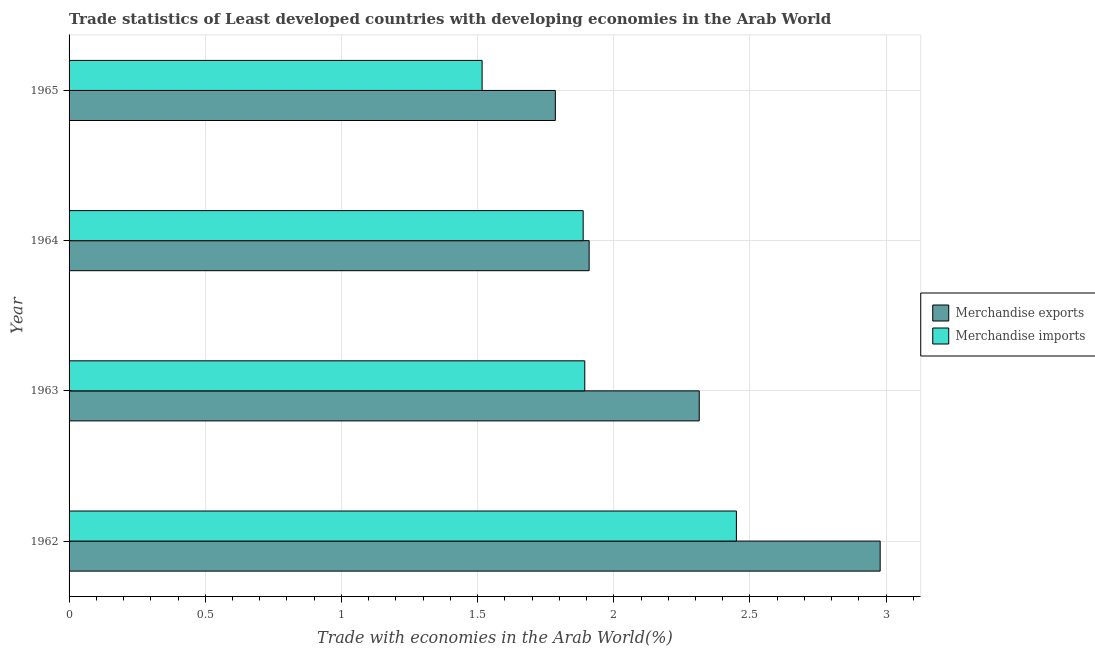How many different coloured bars are there?
Keep it short and to the point. 2. How many groups of bars are there?
Offer a very short reply. 4. Are the number of bars per tick equal to the number of legend labels?
Make the answer very short. Yes. Are the number of bars on each tick of the Y-axis equal?
Provide a short and direct response. Yes. How many bars are there on the 4th tick from the top?
Your response must be concise. 2. What is the label of the 3rd group of bars from the top?
Your answer should be very brief. 1963. In how many cases, is the number of bars for a given year not equal to the number of legend labels?
Offer a very short reply. 0. What is the merchandise exports in 1964?
Your answer should be compact. 1.91. Across all years, what is the maximum merchandise exports?
Offer a terse response. 2.98. Across all years, what is the minimum merchandise exports?
Make the answer very short. 1.79. In which year was the merchandise exports maximum?
Provide a short and direct response. 1962. In which year was the merchandise exports minimum?
Offer a very short reply. 1965. What is the total merchandise imports in the graph?
Your answer should be compact. 7.75. What is the difference between the merchandise imports in 1963 and that in 1965?
Your response must be concise. 0.38. What is the difference between the merchandise exports in 1962 and the merchandise imports in 1964?
Offer a very short reply. 1.09. What is the average merchandise exports per year?
Your answer should be compact. 2.25. In the year 1962, what is the difference between the merchandise exports and merchandise imports?
Your response must be concise. 0.53. In how many years, is the merchandise imports greater than 1.7 %?
Provide a short and direct response. 3. What is the ratio of the merchandise imports in 1962 to that in 1963?
Offer a terse response. 1.29. Is the merchandise imports in 1964 less than that in 1965?
Your answer should be very brief. No. What is the difference between the highest and the second highest merchandise exports?
Provide a short and direct response. 0.66. What is the difference between the highest and the lowest merchandise exports?
Ensure brevity in your answer.  1.19. What does the 2nd bar from the top in 1965 represents?
Keep it short and to the point. Merchandise exports. How many bars are there?
Provide a succinct answer. 8. Are all the bars in the graph horizontal?
Your answer should be compact. Yes. Are the values on the major ticks of X-axis written in scientific E-notation?
Give a very brief answer. No. Does the graph contain grids?
Offer a terse response. Yes. How many legend labels are there?
Offer a very short reply. 2. How are the legend labels stacked?
Provide a succinct answer. Vertical. What is the title of the graph?
Make the answer very short. Trade statistics of Least developed countries with developing economies in the Arab World. What is the label or title of the X-axis?
Ensure brevity in your answer.  Trade with economies in the Arab World(%). What is the label or title of the Y-axis?
Your response must be concise. Year. What is the Trade with economies in the Arab World(%) of Merchandise exports in 1962?
Provide a short and direct response. 2.98. What is the Trade with economies in the Arab World(%) in Merchandise imports in 1962?
Offer a terse response. 2.45. What is the Trade with economies in the Arab World(%) of Merchandise exports in 1963?
Give a very brief answer. 2.31. What is the Trade with economies in the Arab World(%) in Merchandise imports in 1963?
Ensure brevity in your answer.  1.89. What is the Trade with economies in the Arab World(%) in Merchandise exports in 1964?
Keep it short and to the point. 1.91. What is the Trade with economies in the Arab World(%) in Merchandise imports in 1964?
Keep it short and to the point. 1.89. What is the Trade with economies in the Arab World(%) of Merchandise exports in 1965?
Ensure brevity in your answer.  1.79. What is the Trade with economies in the Arab World(%) in Merchandise imports in 1965?
Offer a terse response. 1.52. Across all years, what is the maximum Trade with economies in the Arab World(%) in Merchandise exports?
Provide a short and direct response. 2.98. Across all years, what is the maximum Trade with economies in the Arab World(%) of Merchandise imports?
Ensure brevity in your answer.  2.45. Across all years, what is the minimum Trade with economies in the Arab World(%) in Merchandise exports?
Keep it short and to the point. 1.79. Across all years, what is the minimum Trade with economies in the Arab World(%) of Merchandise imports?
Ensure brevity in your answer.  1.52. What is the total Trade with economies in the Arab World(%) of Merchandise exports in the graph?
Offer a very short reply. 8.99. What is the total Trade with economies in the Arab World(%) of Merchandise imports in the graph?
Provide a short and direct response. 7.75. What is the difference between the Trade with economies in the Arab World(%) of Merchandise exports in 1962 and that in 1963?
Your answer should be very brief. 0.66. What is the difference between the Trade with economies in the Arab World(%) of Merchandise imports in 1962 and that in 1963?
Keep it short and to the point. 0.56. What is the difference between the Trade with economies in the Arab World(%) in Merchandise exports in 1962 and that in 1964?
Offer a terse response. 1.07. What is the difference between the Trade with economies in the Arab World(%) in Merchandise imports in 1962 and that in 1964?
Provide a succinct answer. 0.56. What is the difference between the Trade with economies in the Arab World(%) of Merchandise exports in 1962 and that in 1965?
Provide a short and direct response. 1.19. What is the difference between the Trade with economies in the Arab World(%) in Merchandise imports in 1962 and that in 1965?
Make the answer very short. 0.93. What is the difference between the Trade with economies in the Arab World(%) of Merchandise exports in 1963 and that in 1964?
Your response must be concise. 0.4. What is the difference between the Trade with economies in the Arab World(%) in Merchandise imports in 1963 and that in 1964?
Your answer should be compact. 0.01. What is the difference between the Trade with economies in the Arab World(%) of Merchandise exports in 1963 and that in 1965?
Make the answer very short. 0.53. What is the difference between the Trade with economies in the Arab World(%) of Merchandise imports in 1963 and that in 1965?
Your answer should be very brief. 0.38. What is the difference between the Trade with economies in the Arab World(%) of Merchandise exports in 1964 and that in 1965?
Ensure brevity in your answer.  0.12. What is the difference between the Trade with economies in the Arab World(%) of Merchandise imports in 1964 and that in 1965?
Provide a short and direct response. 0.37. What is the difference between the Trade with economies in the Arab World(%) of Merchandise exports in 1962 and the Trade with economies in the Arab World(%) of Merchandise imports in 1963?
Your answer should be compact. 1.08. What is the difference between the Trade with economies in the Arab World(%) in Merchandise exports in 1962 and the Trade with economies in the Arab World(%) in Merchandise imports in 1964?
Your response must be concise. 1.09. What is the difference between the Trade with economies in the Arab World(%) of Merchandise exports in 1962 and the Trade with economies in the Arab World(%) of Merchandise imports in 1965?
Offer a very short reply. 1.46. What is the difference between the Trade with economies in the Arab World(%) in Merchandise exports in 1963 and the Trade with economies in the Arab World(%) in Merchandise imports in 1964?
Provide a succinct answer. 0.43. What is the difference between the Trade with economies in the Arab World(%) in Merchandise exports in 1963 and the Trade with economies in the Arab World(%) in Merchandise imports in 1965?
Offer a very short reply. 0.8. What is the difference between the Trade with economies in the Arab World(%) of Merchandise exports in 1964 and the Trade with economies in the Arab World(%) of Merchandise imports in 1965?
Provide a succinct answer. 0.39. What is the average Trade with economies in the Arab World(%) in Merchandise exports per year?
Provide a short and direct response. 2.25. What is the average Trade with economies in the Arab World(%) of Merchandise imports per year?
Keep it short and to the point. 1.94. In the year 1962, what is the difference between the Trade with economies in the Arab World(%) in Merchandise exports and Trade with economies in the Arab World(%) in Merchandise imports?
Keep it short and to the point. 0.53. In the year 1963, what is the difference between the Trade with economies in the Arab World(%) of Merchandise exports and Trade with economies in the Arab World(%) of Merchandise imports?
Offer a terse response. 0.42. In the year 1964, what is the difference between the Trade with economies in the Arab World(%) of Merchandise exports and Trade with economies in the Arab World(%) of Merchandise imports?
Give a very brief answer. 0.02. In the year 1965, what is the difference between the Trade with economies in the Arab World(%) of Merchandise exports and Trade with economies in the Arab World(%) of Merchandise imports?
Offer a very short reply. 0.27. What is the ratio of the Trade with economies in the Arab World(%) in Merchandise exports in 1962 to that in 1963?
Offer a very short reply. 1.29. What is the ratio of the Trade with economies in the Arab World(%) of Merchandise imports in 1962 to that in 1963?
Make the answer very short. 1.29. What is the ratio of the Trade with economies in the Arab World(%) of Merchandise exports in 1962 to that in 1964?
Keep it short and to the point. 1.56. What is the ratio of the Trade with economies in the Arab World(%) in Merchandise imports in 1962 to that in 1964?
Provide a succinct answer. 1.3. What is the ratio of the Trade with economies in the Arab World(%) in Merchandise exports in 1962 to that in 1965?
Your answer should be very brief. 1.67. What is the ratio of the Trade with economies in the Arab World(%) of Merchandise imports in 1962 to that in 1965?
Your answer should be compact. 1.62. What is the ratio of the Trade with economies in the Arab World(%) in Merchandise exports in 1963 to that in 1964?
Your answer should be compact. 1.21. What is the ratio of the Trade with economies in the Arab World(%) in Merchandise exports in 1963 to that in 1965?
Give a very brief answer. 1.3. What is the ratio of the Trade with economies in the Arab World(%) of Merchandise imports in 1963 to that in 1965?
Provide a succinct answer. 1.25. What is the ratio of the Trade with economies in the Arab World(%) of Merchandise exports in 1964 to that in 1965?
Keep it short and to the point. 1.07. What is the ratio of the Trade with economies in the Arab World(%) in Merchandise imports in 1964 to that in 1965?
Keep it short and to the point. 1.24. What is the difference between the highest and the second highest Trade with economies in the Arab World(%) of Merchandise exports?
Keep it short and to the point. 0.66. What is the difference between the highest and the second highest Trade with economies in the Arab World(%) of Merchandise imports?
Provide a short and direct response. 0.56. What is the difference between the highest and the lowest Trade with economies in the Arab World(%) in Merchandise exports?
Make the answer very short. 1.19. What is the difference between the highest and the lowest Trade with economies in the Arab World(%) of Merchandise imports?
Make the answer very short. 0.93. 